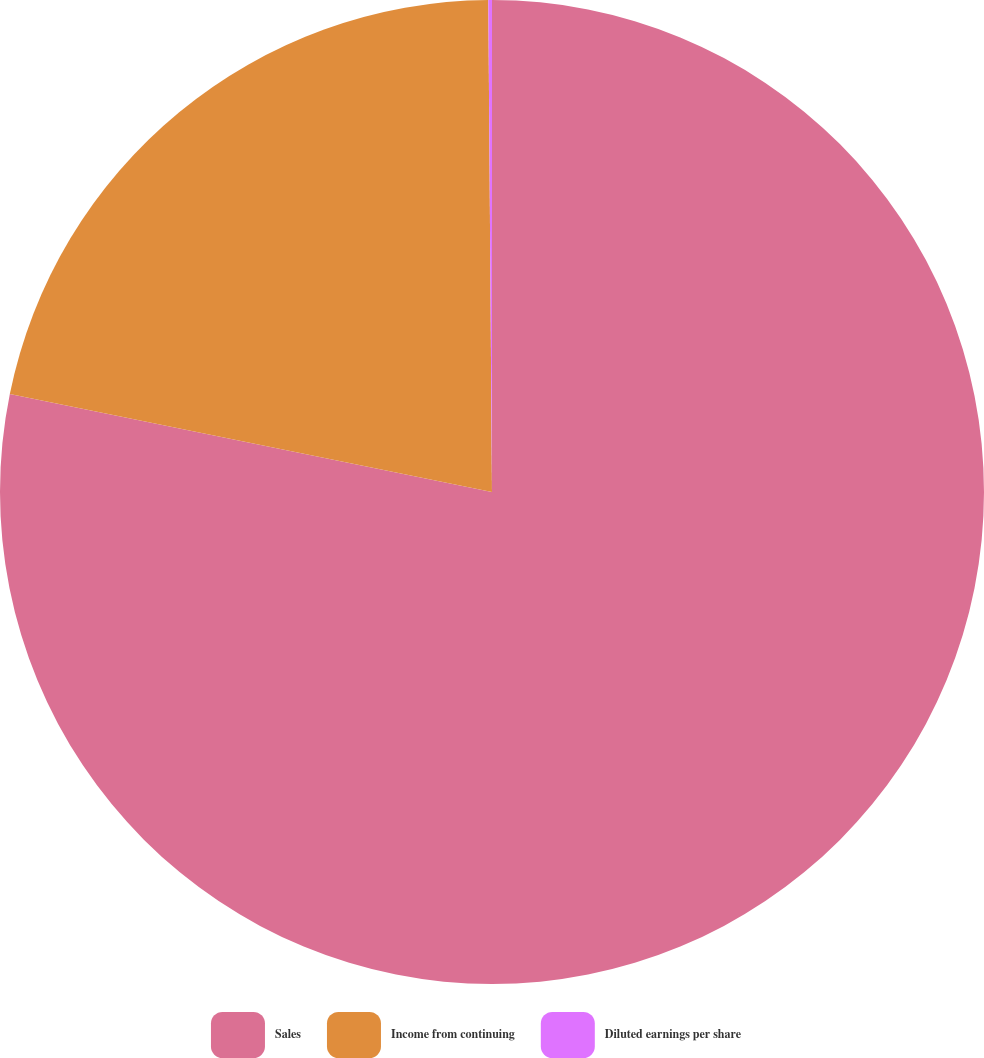Convert chart. <chart><loc_0><loc_0><loc_500><loc_500><pie_chart><fcel>Sales<fcel>Income from continuing<fcel>Diluted earnings per share<nl><fcel>78.18%<fcel>21.69%<fcel>0.12%<nl></chart> 